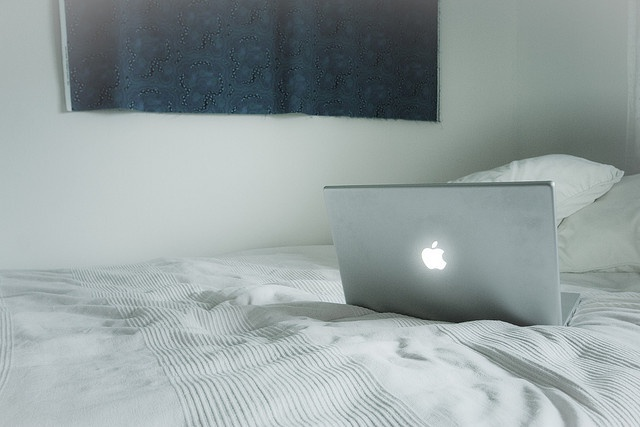Describe the objects in this image and their specific colors. I can see bed in darkgray and lightgray tones and laptop in darkgray, gray, and black tones in this image. 